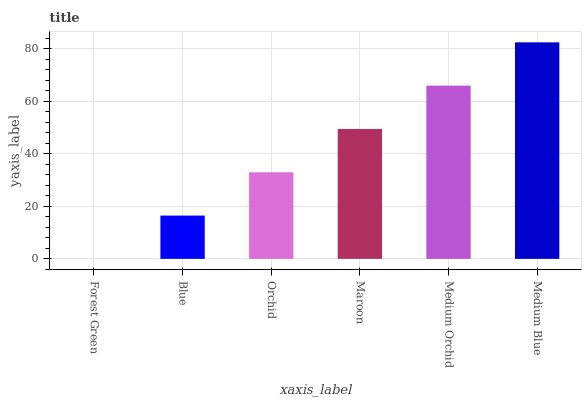Is Blue the minimum?
Answer yes or no. No. Is Blue the maximum?
Answer yes or no. No. Is Blue greater than Forest Green?
Answer yes or no. Yes. Is Forest Green less than Blue?
Answer yes or no. Yes. Is Forest Green greater than Blue?
Answer yes or no. No. Is Blue less than Forest Green?
Answer yes or no. No. Is Maroon the high median?
Answer yes or no. Yes. Is Orchid the low median?
Answer yes or no. Yes. Is Blue the high median?
Answer yes or no. No. Is Forest Green the low median?
Answer yes or no. No. 